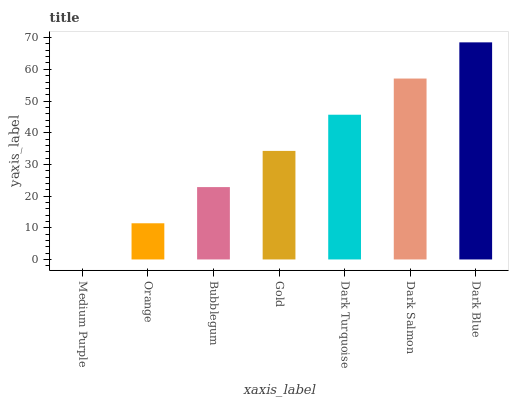Is Medium Purple the minimum?
Answer yes or no. Yes. Is Dark Blue the maximum?
Answer yes or no. Yes. Is Orange the minimum?
Answer yes or no. No. Is Orange the maximum?
Answer yes or no. No. Is Orange greater than Medium Purple?
Answer yes or no. Yes. Is Medium Purple less than Orange?
Answer yes or no. Yes. Is Medium Purple greater than Orange?
Answer yes or no. No. Is Orange less than Medium Purple?
Answer yes or no. No. Is Gold the high median?
Answer yes or no. Yes. Is Gold the low median?
Answer yes or no. Yes. Is Orange the high median?
Answer yes or no. No. Is Orange the low median?
Answer yes or no. No. 